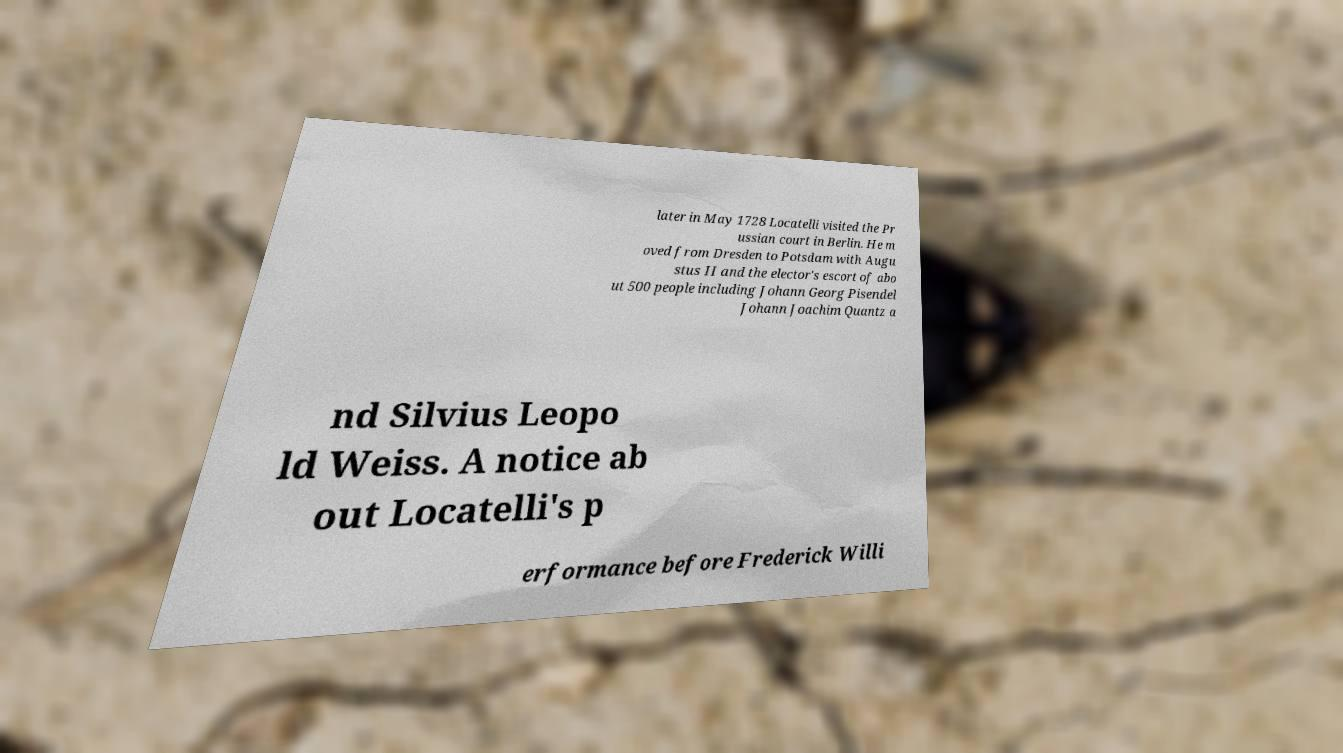Please read and relay the text visible in this image. What does it say? later in May 1728 Locatelli visited the Pr ussian court in Berlin. He m oved from Dresden to Potsdam with Augu stus II and the elector's escort of abo ut 500 people including Johann Georg Pisendel Johann Joachim Quantz a nd Silvius Leopo ld Weiss. A notice ab out Locatelli's p erformance before Frederick Willi 